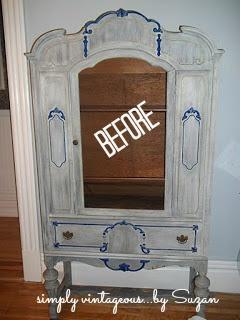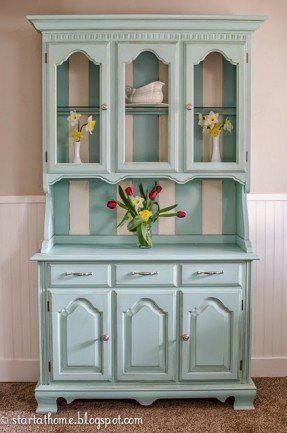The first image is the image on the left, the second image is the image on the right. Evaluate the accuracy of this statement regarding the images: "One wooden hutch has a pair of doors and flat top, while the other has a single centered glass door and rounded decorative detail at the top.". Is it true? Answer yes or no. No. 